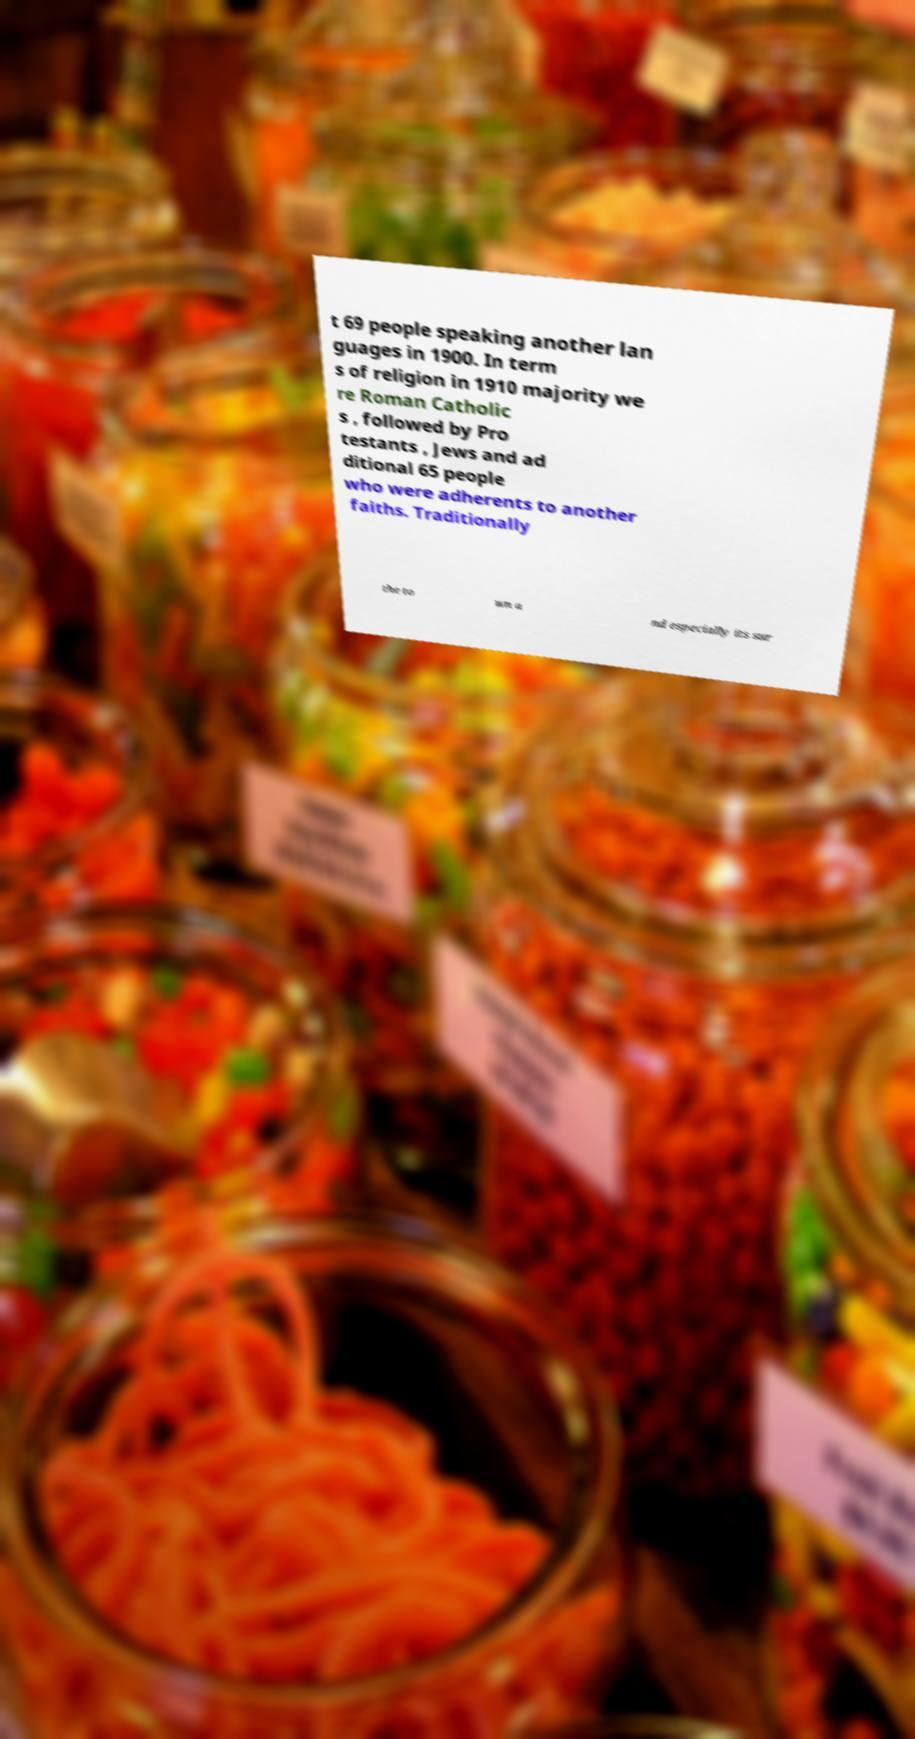For documentation purposes, I need the text within this image transcribed. Could you provide that? t 69 people speaking another lan guages in 1900. In term s of religion in 1910 majority we re Roman Catholic s , followed by Pro testants , Jews and ad ditional 65 people who were adherents to another faiths. Traditionally the to wn a nd especially its sur 